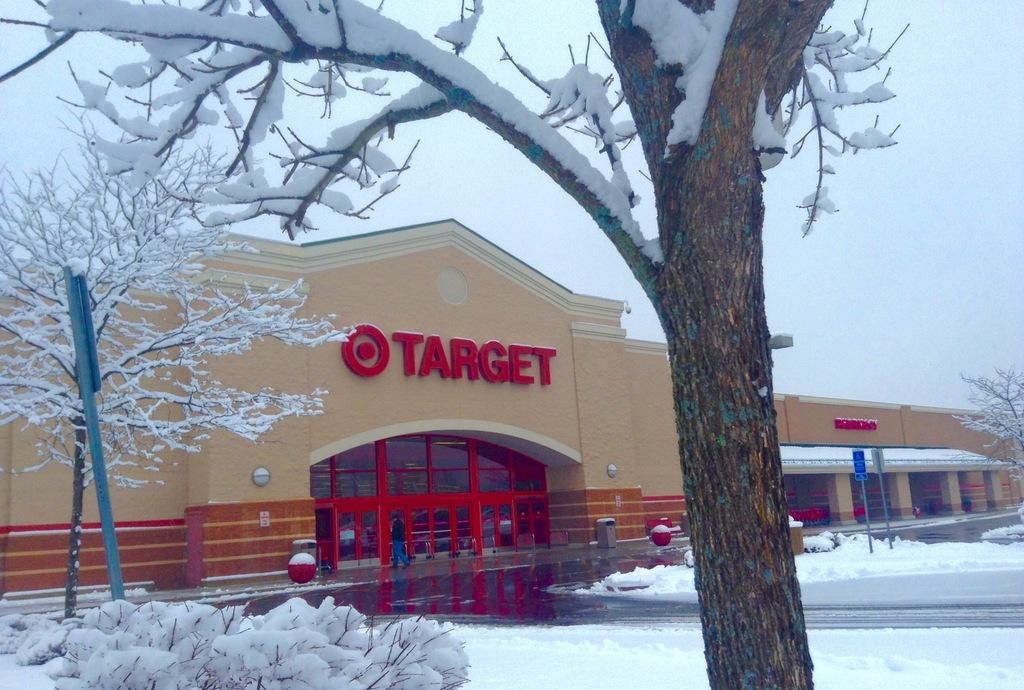Describe this image in one or two sentences. In this picture we can see a building, poles, boards, bins, balls, and snow. There are plants and trees covered with snow. In the background there is sky. 